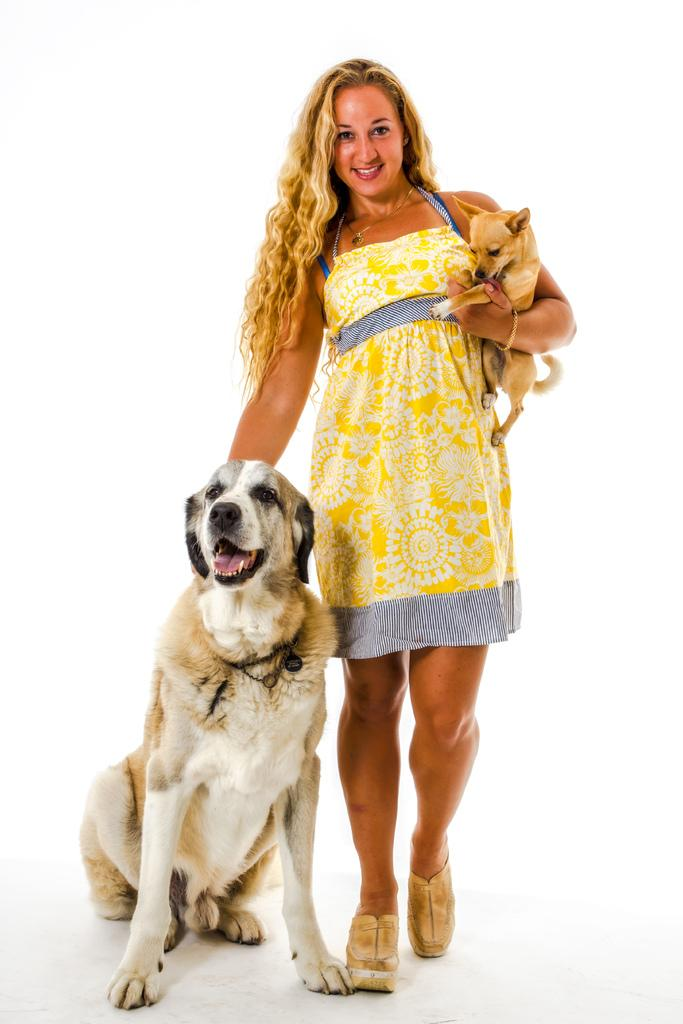Who is present in the image? There is a woman in the image. What is the woman wearing? The woman is wearing a yellow dress. What is the woman doing in the image? The woman is walking and smiling. What is the woman holding in the image? The woman is holding two dogs. Can you describe the dogs? One dog is white, and the other dog is yellow. What is the background of the image? The background is white. What type of laborer is working in the background of the image? There is no laborer present in the image; the background is white. What advice would the woman's grandmother give her in the image? There is no grandmother present in the image, so it is not possible to determine what advice she might give. 